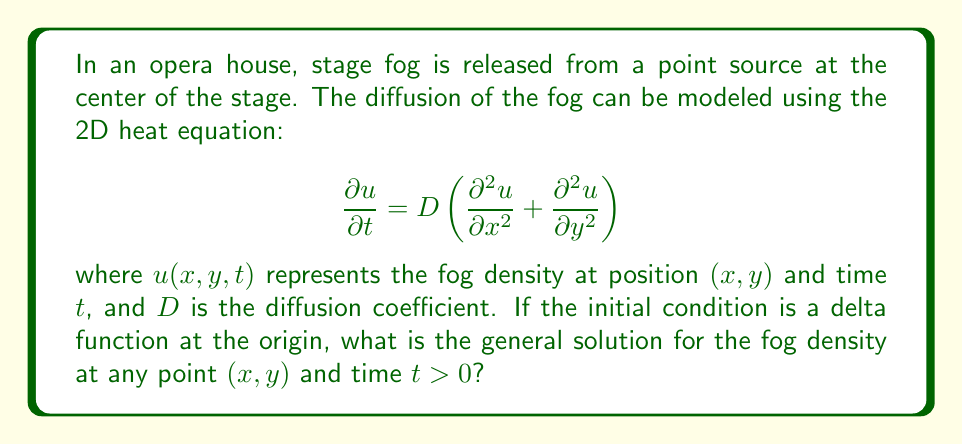What is the answer to this math problem? Let's approach this step-by-step:

1) The given equation is the 2D heat equation, which in this case models the diffusion of stage fog.

2) The initial condition is a delta function at the origin, which represents a point source of fog at the center of the stage. Mathematically, this can be written as:

   $$u(x,y,0) = \delta(x)\delta(y)$$

3) For a 2D heat equation with a delta function initial condition, the solution is known to be a Gaussian function. The general form of this solution is:

   $$u(x,y,t) = \frac{1}{4\pi Dt} e^{-\frac{x^2+y^2}{4Dt}}$$

4) Let's verify that this solution satisfies the heat equation:

   $$\frac{\partial u}{\partial t} = \frac{1}{4\pi D} \cdot \frac{-1}{t^2} e^{-\frac{x^2+y^2}{4Dt}} + \frac{1}{4\pi Dt} \cdot \frac{x^2+y^2}{4Dt^2} e^{-\frac{x^2+y^2}{4Dt}}$$

   $$\frac{\partial^2 u}{\partial x^2} = \frac{1}{4\pi Dt} \cdot \frac{-1}{2Dt} e^{-\frac{x^2+y^2}{4Dt}} + \frac{1}{4\pi Dt} \cdot \frac{x^2}{4D^2t^2} e^{-\frac{x^2+y^2}{4Dt}}$$

   $$\frac{\partial^2 u}{\partial y^2} = \frac{1}{4\pi Dt} \cdot \frac{-1}{2Dt} e^{-\frac{x^2+y^2}{4Dt}} + \frac{1}{4\pi Dt} \cdot \frac{y^2}{4D^2t^2} e^{-\frac{x^2+y^2}{4Dt}}$$

5) Adding the second derivatives and multiplying by $D$:

   $$D\left(\frac{\partial^2 u}{\partial x^2} + \frac{\partial^2 u}{\partial y^2}\right) = \frac{1}{4\pi D} \cdot \frac{-1}{t^2} e^{-\frac{x^2+y^2}{4Dt}} + \frac{1}{4\pi Dt} \cdot \frac{x^2+y^2}{4Dt^2} e^{-\frac{x^2+y^2}{4Dt}}$$

6) This is identical to $\frac{\partial u}{\partial t}$, verifying that the solution satisfies the heat equation.

7) As $t \to 0$, this solution approaches a delta function, satisfying the initial condition.

Therefore, the given solution is the correct general solution for the fog density.
Answer: $$u(x,y,t) = \frac{1}{4\pi Dt} e^{-\frac{x^2+y^2}{4Dt}}$$ 